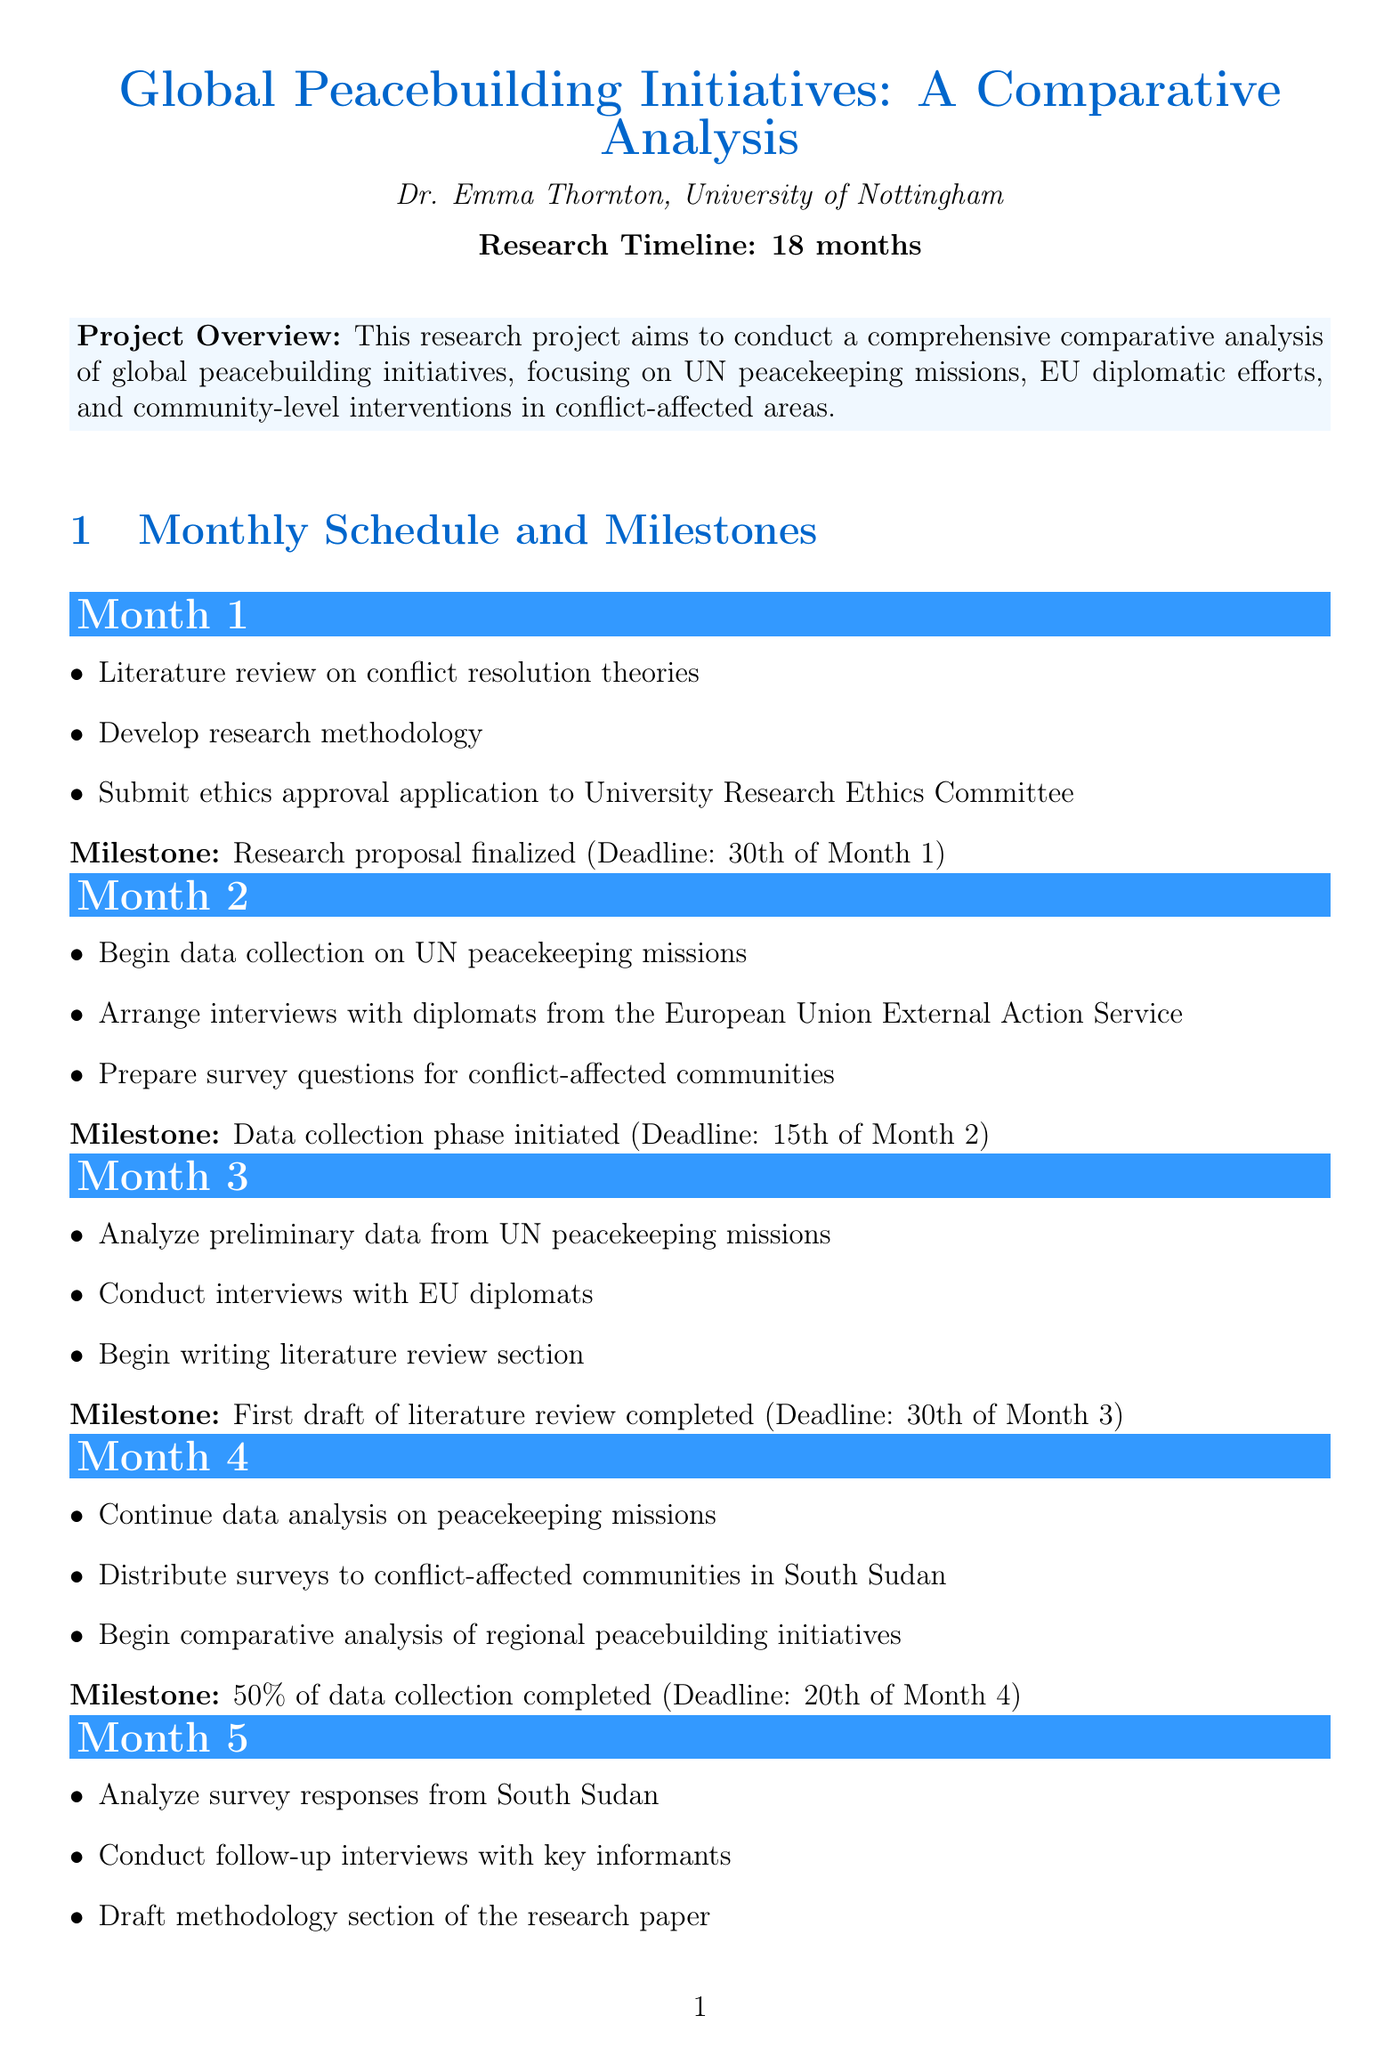What is the project title? The project title is stated at the beginning of the document, specifically "Global Peacebuilding Initiatives: A Comparative Analysis."
Answer: Global Peacebuilding Initiatives: A Comparative Analysis Who is the principal investigator? The document mentions Dr. Emma Thornton as the principal investigator of the project.
Answer: Dr. Emma Thornton What is the deadline for the first milestone? The document specifies the deadline for the first milestone, which is the finalization of the research proposal.
Answer: 30th of Month 1 How many months is the research timeline? The document clearly indicates that the research timeline spans 18 months.
Answer: 18 months What is the milestone for Month 6? The milestone for Month 6 is noted as the delivery of the conference presentation, marking a significant progress point.
Answer: Conference presentation delivered In which month is the first draft of the research paper completed? The document states that the first draft of the research paper is to be completed by Month 8.
Answer: Month 8 What activity is scheduled for Month 14? Activities for Month 14 are listed, including conducting a webinar series on research findings for practitioners.
Answer: Conduct webinar series on research findings for practitioners When is the final project report due? According to the document, the final project report is to be submitted by the end of Month 18.
Answer: 30th of Month 18 What percentage of data collection is completed by Month 4? The document clearly states that 50% of data collection is expected to be completed by Month 4.
Answer: 50% 